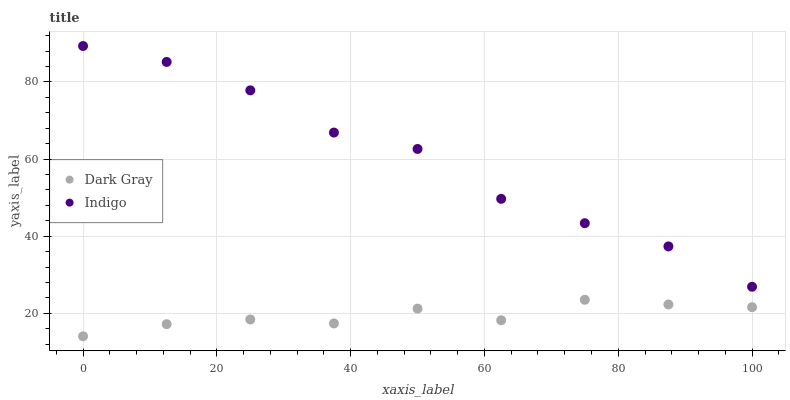Does Dark Gray have the minimum area under the curve?
Answer yes or no. Yes. Does Indigo have the maximum area under the curve?
Answer yes or no. Yes. Does Indigo have the minimum area under the curve?
Answer yes or no. No. Is Dark Gray the smoothest?
Answer yes or no. Yes. Is Indigo the roughest?
Answer yes or no. Yes. Is Indigo the smoothest?
Answer yes or no. No. Does Dark Gray have the lowest value?
Answer yes or no. Yes. Does Indigo have the lowest value?
Answer yes or no. No. Does Indigo have the highest value?
Answer yes or no. Yes. Is Dark Gray less than Indigo?
Answer yes or no. Yes. Is Indigo greater than Dark Gray?
Answer yes or no. Yes. Does Dark Gray intersect Indigo?
Answer yes or no. No. 